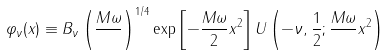Convert formula to latex. <formula><loc_0><loc_0><loc_500><loc_500>\varphi _ { \nu } ( x ) \equiv B _ { \nu } \left ( \frac { M \omega } { } \right ) ^ { 1 / 4 } \exp \left [ - \frac { M \omega } { 2 } x ^ { 2 } \right ] U \left ( - \nu , \frac { 1 } { 2 } ; \frac { M \omega } { } x ^ { 2 } \right )</formula> 